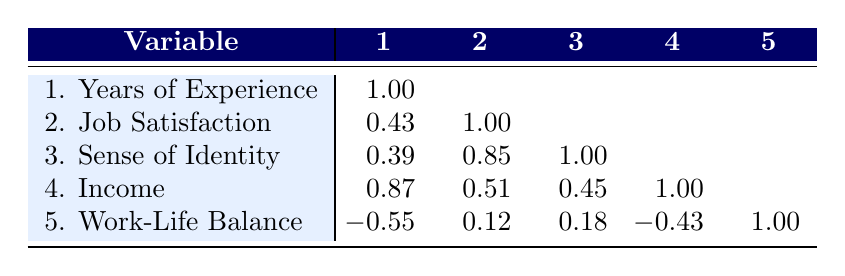What is the correlation between job satisfaction and sense of identity? The correlation between job satisfaction (2) and sense of identity (3) is 0.85 as shown in the table.
Answer: 0.85 Which occupation has the highest income? By comparing the income values for each occupation, Fashion Designer has the highest income of 72000.
Answer: Fashion Designer What is the average years of experience for all occupations listed? The years of experience values are 5, 3, 8, 4, 6, 10, 12, 7, 4, and 9. Adding them gives 5 + 3 + 8 + 4 + 6 + 10 + 12 + 7 + 4 + 9 = 68. There are 10 data points, so the average is 68/10 = 6.8.
Answer: 6.8 Is there a negative correlation between work-life balance and job satisfaction? The correlation coefficient between work-life balance (5) and job satisfaction (2) is 0.12, indicating no significant negative correlation. So, the statement is false.
Answer: No What is the combined correlation between income and years of experience, and how does that relate to job satisfaction? The correlation between income (4) and years of experience (1) is 0.87, which indicates a strong positive relationship. Comparing this with job satisfaction (2) which has a correlation of 0.51 with income, we can see that while experience relates highly to income, its effect on job satisfaction is less strong. So while years of experience significantly impacts income, it doesn't contribute as much to job satisfaction directly.
Answer: Strong positive relationship but less impact on job satisfaction 